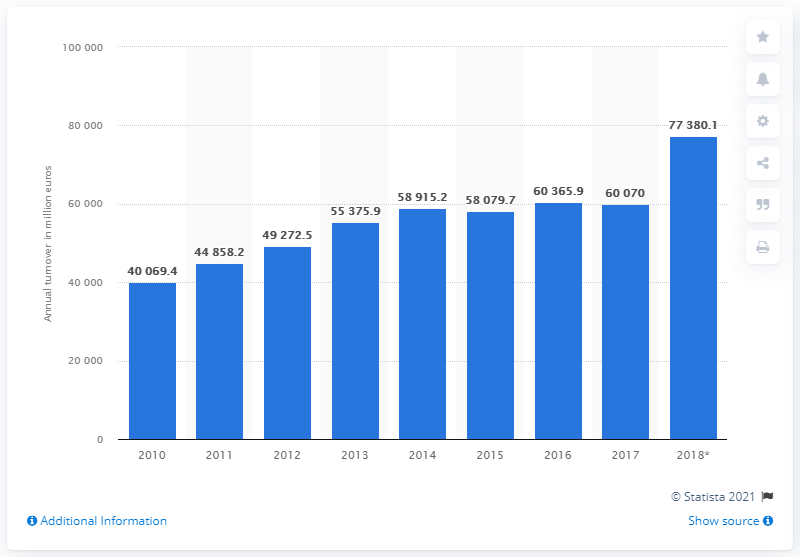Point out several critical features in this image. The turnover of the building construction industry in Germany in 2017 was approximately 77,380.1. In 2017, the turnover of the building construction industry in Germany was approximately 600,700. 